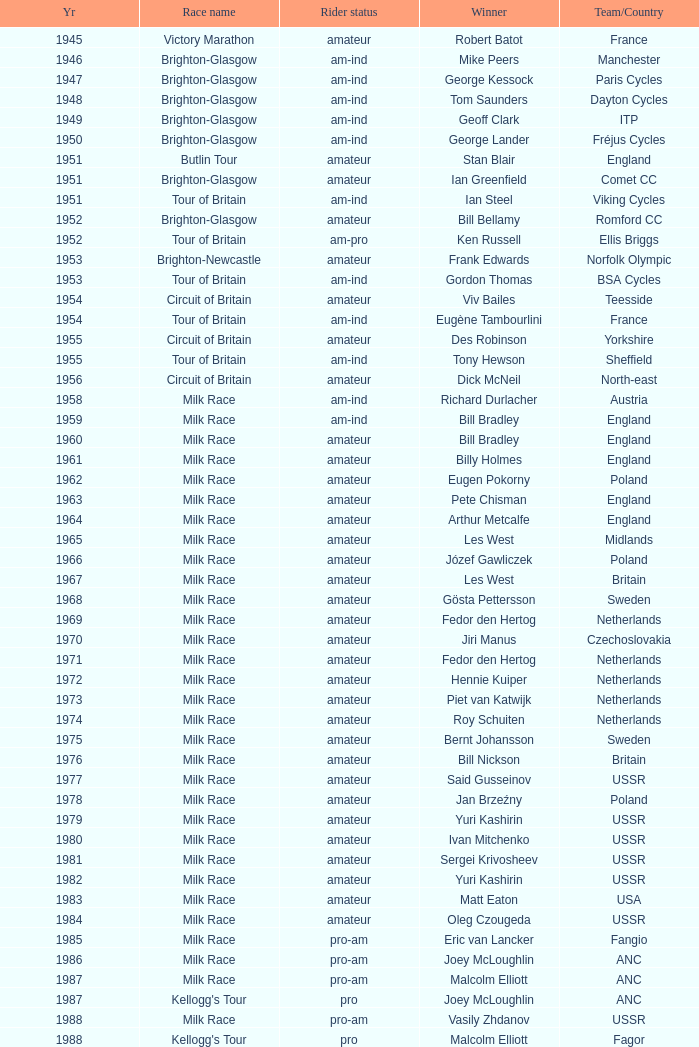Who was the winner in 1973 with an amateur rider status? Piet van Katwijk. 